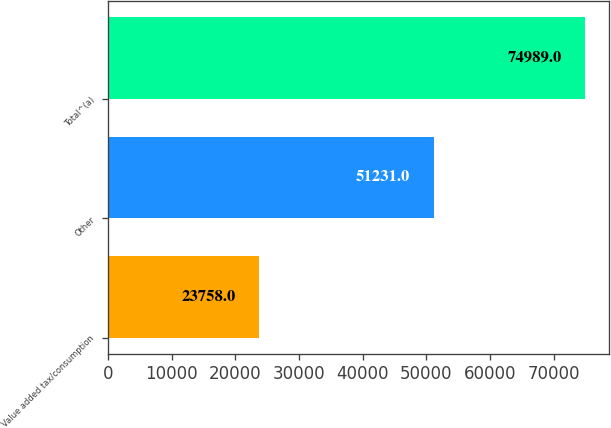Convert chart to OTSL. <chart><loc_0><loc_0><loc_500><loc_500><bar_chart><fcel>Value added tax/consumption<fcel>Other<fcel>Total^(a)<nl><fcel>23758<fcel>51231<fcel>74989<nl></chart> 